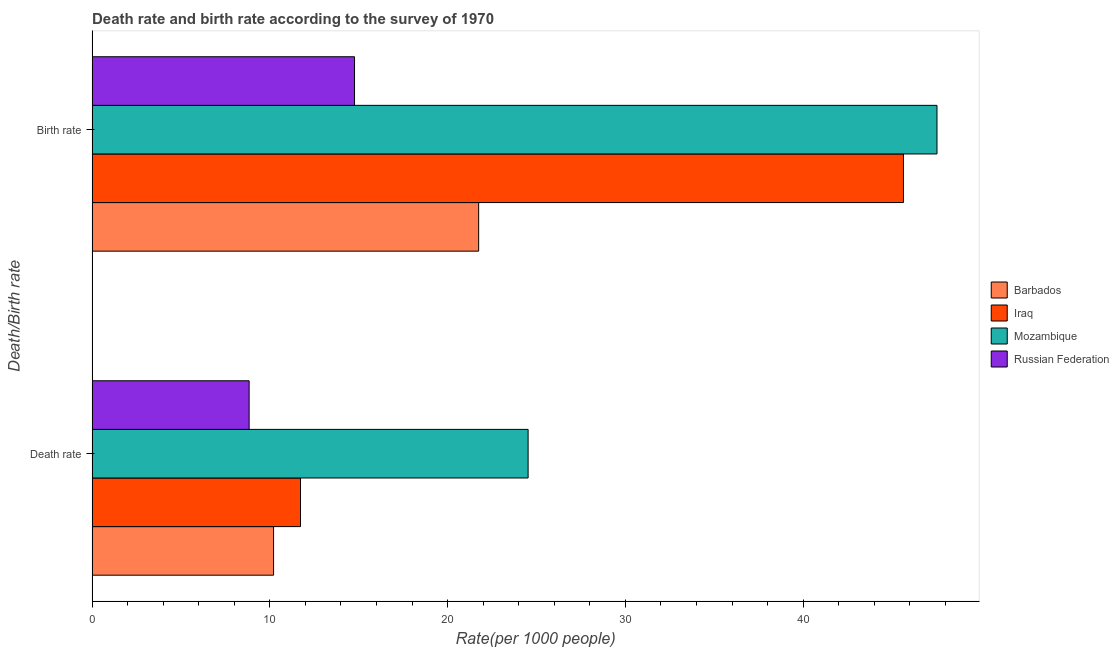How many different coloured bars are there?
Your response must be concise. 4. Are the number of bars per tick equal to the number of legend labels?
Offer a very short reply. Yes. How many bars are there on the 1st tick from the top?
Your response must be concise. 4. What is the label of the 2nd group of bars from the top?
Ensure brevity in your answer.  Death rate. What is the death rate in Barbados?
Provide a succinct answer. 10.21. Across all countries, what is the maximum birth rate?
Provide a short and direct response. 47.53. Across all countries, what is the minimum death rate?
Make the answer very short. 8.83. In which country was the birth rate maximum?
Offer a terse response. Mozambique. In which country was the death rate minimum?
Make the answer very short. Russian Federation. What is the total birth rate in the graph?
Your answer should be very brief. 129.68. What is the difference between the birth rate in Mozambique and that in Barbados?
Ensure brevity in your answer.  25.78. What is the difference between the death rate in Mozambique and the birth rate in Iraq?
Your answer should be very brief. -21.12. What is the average birth rate per country?
Your response must be concise. 32.42. What is the difference between the birth rate and death rate in Russian Federation?
Your answer should be very brief. 5.93. What is the ratio of the death rate in Iraq to that in Mozambique?
Your answer should be very brief. 0.48. Is the death rate in Barbados less than that in Mozambique?
Your response must be concise. Yes. In how many countries, is the death rate greater than the average death rate taken over all countries?
Offer a very short reply. 1. What does the 2nd bar from the top in Death rate represents?
Offer a terse response. Mozambique. What does the 2nd bar from the bottom in Death rate represents?
Your response must be concise. Iraq. How many countries are there in the graph?
Offer a terse response. 4. What is the difference between two consecutive major ticks on the X-axis?
Provide a short and direct response. 10. Does the graph contain any zero values?
Keep it short and to the point. No. Where does the legend appear in the graph?
Provide a short and direct response. Center right. What is the title of the graph?
Your answer should be very brief. Death rate and birth rate according to the survey of 1970. What is the label or title of the X-axis?
Keep it short and to the point. Rate(per 1000 people). What is the label or title of the Y-axis?
Keep it short and to the point. Death/Birth rate. What is the Rate(per 1000 people) in Barbados in Death rate?
Your response must be concise. 10.21. What is the Rate(per 1000 people) in Iraq in Death rate?
Your response must be concise. 11.72. What is the Rate(per 1000 people) of Mozambique in Death rate?
Ensure brevity in your answer.  24.53. What is the Rate(per 1000 people) in Russian Federation in Death rate?
Ensure brevity in your answer.  8.83. What is the Rate(per 1000 people) in Barbados in Birth rate?
Offer a terse response. 21.75. What is the Rate(per 1000 people) of Iraq in Birth rate?
Make the answer very short. 45.64. What is the Rate(per 1000 people) in Mozambique in Birth rate?
Ensure brevity in your answer.  47.53. What is the Rate(per 1000 people) in Russian Federation in Birth rate?
Provide a short and direct response. 14.76. Across all Death/Birth rate, what is the maximum Rate(per 1000 people) in Barbados?
Offer a terse response. 21.75. Across all Death/Birth rate, what is the maximum Rate(per 1000 people) in Iraq?
Provide a short and direct response. 45.64. Across all Death/Birth rate, what is the maximum Rate(per 1000 people) of Mozambique?
Ensure brevity in your answer.  47.53. Across all Death/Birth rate, what is the maximum Rate(per 1000 people) of Russian Federation?
Offer a very short reply. 14.76. Across all Death/Birth rate, what is the minimum Rate(per 1000 people) of Barbados?
Offer a very short reply. 10.21. Across all Death/Birth rate, what is the minimum Rate(per 1000 people) of Iraq?
Your answer should be very brief. 11.72. Across all Death/Birth rate, what is the minimum Rate(per 1000 people) in Mozambique?
Make the answer very short. 24.53. Across all Death/Birth rate, what is the minimum Rate(per 1000 people) in Russian Federation?
Offer a very short reply. 8.83. What is the total Rate(per 1000 people) in Barbados in the graph?
Offer a very short reply. 31.95. What is the total Rate(per 1000 people) in Iraq in the graph?
Offer a very short reply. 57.37. What is the total Rate(per 1000 people) in Mozambique in the graph?
Your answer should be very brief. 72.06. What is the total Rate(per 1000 people) in Russian Federation in the graph?
Provide a short and direct response. 23.6. What is the difference between the Rate(per 1000 people) of Barbados in Death rate and that in Birth rate?
Keep it short and to the point. -11.54. What is the difference between the Rate(per 1000 people) in Iraq in Death rate and that in Birth rate?
Your answer should be compact. -33.92. What is the difference between the Rate(per 1000 people) in Mozambique in Death rate and that in Birth rate?
Ensure brevity in your answer.  -23. What is the difference between the Rate(per 1000 people) of Russian Federation in Death rate and that in Birth rate?
Give a very brief answer. -5.93. What is the difference between the Rate(per 1000 people) of Barbados in Death rate and the Rate(per 1000 people) of Iraq in Birth rate?
Offer a terse response. -35.44. What is the difference between the Rate(per 1000 people) in Barbados in Death rate and the Rate(per 1000 people) in Mozambique in Birth rate?
Keep it short and to the point. -37.32. What is the difference between the Rate(per 1000 people) of Barbados in Death rate and the Rate(per 1000 people) of Russian Federation in Birth rate?
Your answer should be very brief. -4.55. What is the difference between the Rate(per 1000 people) in Iraq in Death rate and the Rate(per 1000 people) in Mozambique in Birth rate?
Your answer should be compact. -35.8. What is the difference between the Rate(per 1000 people) in Iraq in Death rate and the Rate(per 1000 people) in Russian Federation in Birth rate?
Offer a terse response. -3.04. What is the difference between the Rate(per 1000 people) in Mozambique in Death rate and the Rate(per 1000 people) in Russian Federation in Birth rate?
Ensure brevity in your answer.  9.77. What is the average Rate(per 1000 people) of Barbados per Death/Birth rate?
Offer a very short reply. 15.98. What is the average Rate(per 1000 people) in Iraq per Death/Birth rate?
Offer a very short reply. 28.68. What is the average Rate(per 1000 people) of Mozambique per Death/Birth rate?
Offer a terse response. 36.03. What is the average Rate(per 1000 people) in Russian Federation per Death/Birth rate?
Ensure brevity in your answer.  11.8. What is the difference between the Rate(per 1000 people) of Barbados and Rate(per 1000 people) of Iraq in Death rate?
Make the answer very short. -1.52. What is the difference between the Rate(per 1000 people) in Barbados and Rate(per 1000 people) in Mozambique in Death rate?
Provide a succinct answer. -14.32. What is the difference between the Rate(per 1000 people) of Barbados and Rate(per 1000 people) of Russian Federation in Death rate?
Keep it short and to the point. 1.38. What is the difference between the Rate(per 1000 people) in Iraq and Rate(per 1000 people) in Mozambique in Death rate?
Keep it short and to the point. -12.8. What is the difference between the Rate(per 1000 people) in Iraq and Rate(per 1000 people) in Russian Federation in Death rate?
Your answer should be very brief. 2.89. What is the difference between the Rate(per 1000 people) of Mozambique and Rate(per 1000 people) of Russian Federation in Death rate?
Provide a short and direct response. 15.69. What is the difference between the Rate(per 1000 people) of Barbados and Rate(per 1000 people) of Iraq in Birth rate?
Offer a very short reply. -23.9. What is the difference between the Rate(per 1000 people) in Barbados and Rate(per 1000 people) in Mozambique in Birth rate?
Your answer should be very brief. -25.78. What is the difference between the Rate(per 1000 people) in Barbados and Rate(per 1000 people) in Russian Federation in Birth rate?
Your answer should be very brief. 6.98. What is the difference between the Rate(per 1000 people) in Iraq and Rate(per 1000 people) in Mozambique in Birth rate?
Offer a very short reply. -1.89. What is the difference between the Rate(per 1000 people) in Iraq and Rate(per 1000 people) in Russian Federation in Birth rate?
Offer a terse response. 30.88. What is the difference between the Rate(per 1000 people) in Mozambique and Rate(per 1000 people) in Russian Federation in Birth rate?
Make the answer very short. 32.77. What is the ratio of the Rate(per 1000 people) in Barbados in Death rate to that in Birth rate?
Your answer should be very brief. 0.47. What is the ratio of the Rate(per 1000 people) of Iraq in Death rate to that in Birth rate?
Give a very brief answer. 0.26. What is the ratio of the Rate(per 1000 people) in Mozambique in Death rate to that in Birth rate?
Keep it short and to the point. 0.52. What is the ratio of the Rate(per 1000 people) of Russian Federation in Death rate to that in Birth rate?
Ensure brevity in your answer.  0.6. What is the difference between the highest and the second highest Rate(per 1000 people) in Barbados?
Ensure brevity in your answer.  11.54. What is the difference between the highest and the second highest Rate(per 1000 people) in Iraq?
Offer a terse response. 33.92. What is the difference between the highest and the second highest Rate(per 1000 people) in Mozambique?
Offer a very short reply. 23. What is the difference between the highest and the second highest Rate(per 1000 people) in Russian Federation?
Your answer should be very brief. 5.93. What is the difference between the highest and the lowest Rate(per 1000 people) in Barbados?
Provide a short and direct response. 11.54. What is the difference between the highest and the lowest Rate(per 1000 people) of Iraq?
Provide a succinct answer. 33.92. What is the difference between the highest and the lowest Rate(per 1000 people) of Mozambique?
Ensure brevity in your answer.  23. What is the difference between the highest and the lowest Rate(per 1000 people) of Russian Federation?
Your answer should be compact. 5.93. 